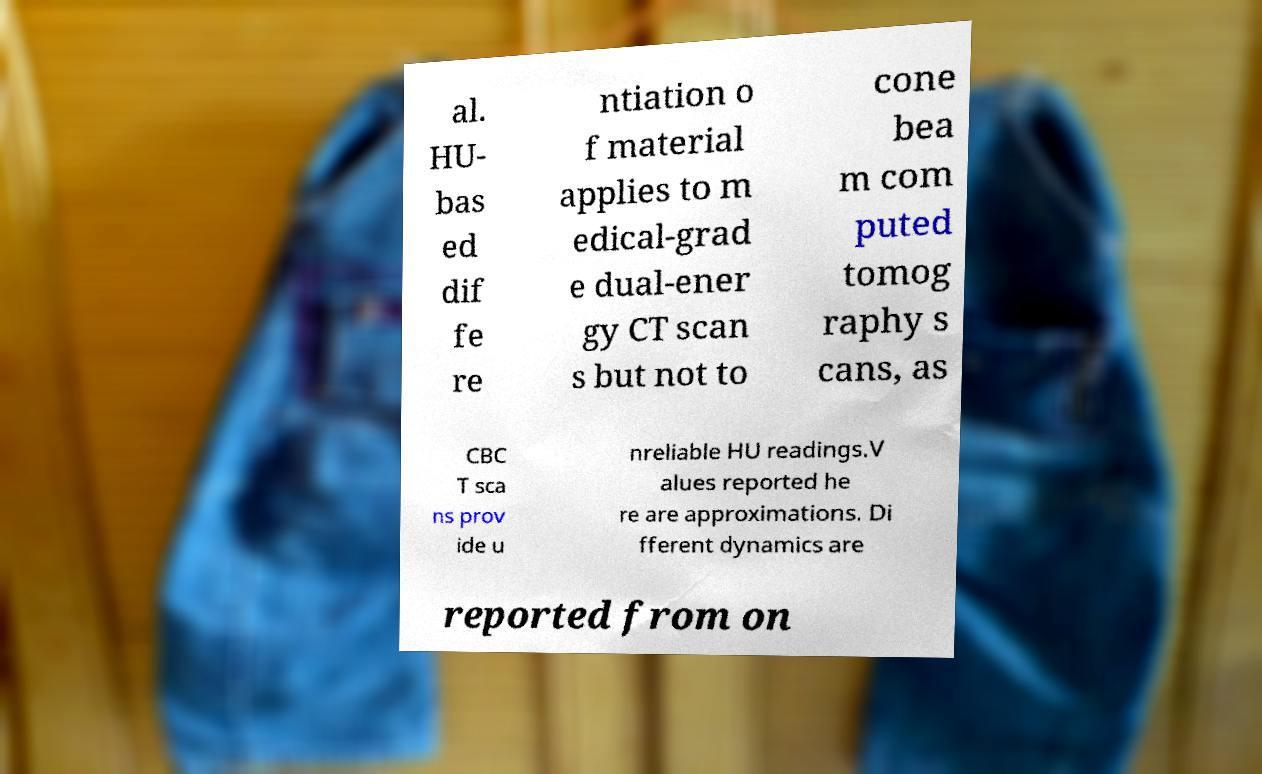Can you read and provide the text displayed in the image?This photo seems to have some interesting text. Can you extract and type it out for me? al. HU- bas ed dif fe re ntiation o f material applies to m edical-grad e dual-ener gy CT scan s but not to cone bea m com puted tomog raphy s cans, as CBC T sca ns prov ide u nreliable HU readings.V alues reported he re are approximations. Di fferent dynamics are reported from on 